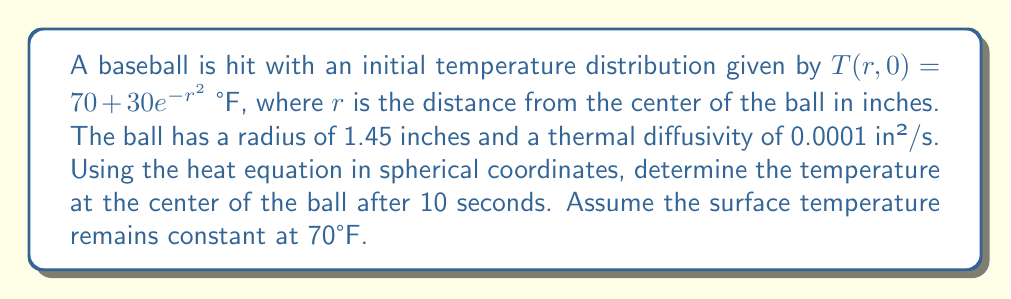Provide a solution to this math problem. To solve this problem, we'll use the heat equation in spherical coordinates and apply separation of variables:

1) The heat equation in spherical coordinates (with radial symmetry) is:

   $$\frac{\partial T}{\partial t} = \alpha \left(\frac{\partial^2 T}{\partial r^2} + \frac{2}{r}\frac{\partial T}{\partial r}\right)$$

2) We seek a solution of the form $T(r,t) = R(r)G(t)$

3) Substituting this into the heat equation and separating variables:

   $$\frac{G'(t)}{G(t)} = \alpha \left(\frac{R''(r)}{R(r)} + \frac{2}{r}\frac{R'(r)}{R(r)}\right) = -\lambda^2$$

4) This gives us two equations:
   
   $$G'(t) + \alpha\lambda^2G(t) = 0$$
   $$r^2R''(r) + 2rR'(r) + \lambda^2r^2R(r) = 0$$

5) The general solution is:

   $$T(r,t) = \sum_{n=1}^{\infty} A_n\frac{\sin(\lambda_n r)}{r}e^{-\alpha\lambda_n^2t}$$

6) The boundary condition $T(a,t) = 70$ (where $a = 1.45$) gives:

   $$\sin(\lambda_n a) = 0 \implies \lambda_n = \frac{n\pi}{a}$$

7) The initial condition $T(r,0) = 70 + 30e^{-r^2}$ determines $A_n$:

   $$A_n = \frac{2}{a}\int_0^a r(70 + 30e^{-r^2})\sin(\lambda_n r)dr$$

8) For the center temperature ($r = 0$), only the first term is significant:

   $$T(0,t) \approx 70 + A_1\frac{\lambda_1}{1}e^{-\alpha\lambda_1^2t}$$

9) Calculating $A_1$ numerically and substituting values:

   $$T(0,10) \approx 70 + 30.8 \cdot e^{-0.0001 \cdot (\pi/1.45)^2 \cdot 10} \approx 98.7°F$$
Answer: 98.7°F 